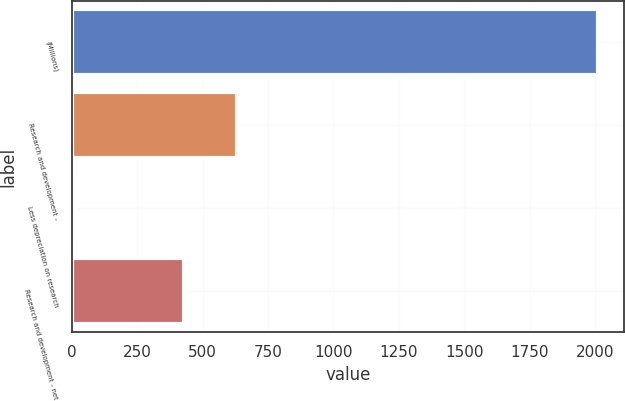<chart> <loc_0><loc_0><loc_500><loc_500><bar_chart><fcel>(Millions)<fcel>Research and development -<fcel>Less depreciation on research<fcel>Research and development - net<nl><fcel>2011<fcel>629.6<fcel>15<fcel>430<nl></chart> 